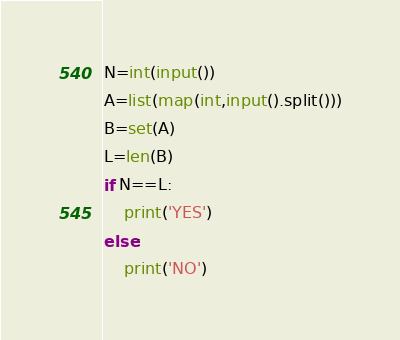<code> <loc_0><loc_0><loc_500><loc_500><_Python_>N=int(input())
A=list(map(int,input().split()))
B=set(A)
L=len(B)
if N==L:
	print('YES')
else:
	print('NO')</code> 